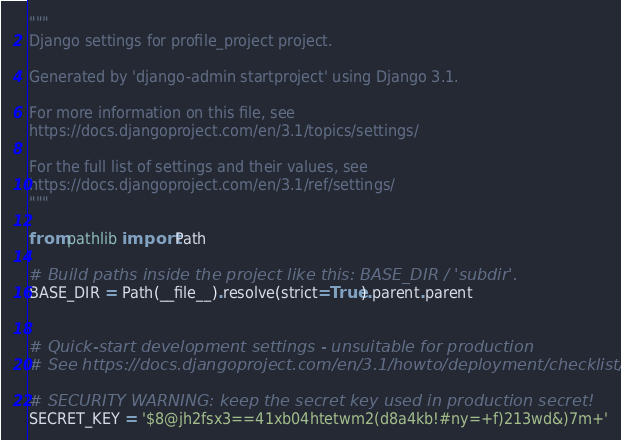<code> <loc_0><loc_0><loc_500><loc_500><_Python_>"""
Django settings for profile_project project.

Generated by 'django-admin startproject' using Django 3.1.

For more information on this file, see
https://docs.djangoproject.com/en/3.1/topics/settings/

For the full list of settings and their values, see
https://docs.djangoproject.com/en/3.1/ref/settings/
"""

from pathlib import Path

# Build paths inside the project like this: BASE_DIR / 'subdir'.
BASE_DIR = Path(__file__).resolve(strict=True).parent.parent


# Quick-start development settings - unsuitable for production
# See https://docs.djangoproject.com/en/3.1/howto/deployment/checklist/

# SECURITY WARNING: keep the secret key used in production secret!
SECRET_KEY = '$8@jh2fsx3==41xb04htetwm2(d8a4kb!#ny=+f)213wd&)7m+'
</code> 